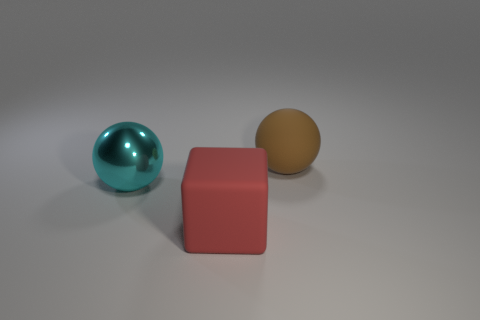There is a cyan thing that is the same shape as the brown thing; what size is it?
Make the answer very short. Large. Does the matte ball have the same color as the metallic object?
Keep it short and to the point. No. How many other objects are the same material as the brown thing?
Keep it short and to the point. 1. Are there the same number of big things to the left of the big brown ball and matte cubes?
Your answer should be very brief. No. There is a matte thing in front of the brown sphere; does it have the same size as the brown sphere?
Give a very brief answer. Yes. How many spheres are behind the large brown object?
Give a very brief answer. 0. There is a thing that is both behind the red block and on the right side of the big shiny object; what material is it?
Offer a very short reply. Rubber. How many large objects are either rubber spheres or metallic objects?
Make the answer very short. 2. The red cube has what size?
Your answer should be compact. Large. What is the shape of the big red object?
Offer a very short reply. Cube. 